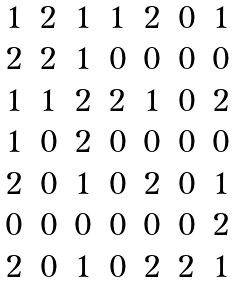<formula> <loc_0><loc_0><loc_500><loc_500>\begin{matrix} 1 & 2 & 1 & 1 & 2 & 0 & 1 \\ 2 & 2 & 1 & 0 & 0 & 0 & 0 \\ 1 & 1 & 2 & 2 & 1 & 0 & 2 \\ 1 & 0 & 2 & 0 & 0 & 0 & 0 \\ 2 & 0 & 1 & 0 & 2 & 0 & 1 \\ 0 & 0 & 0 & 0 & 0 & 0 & 2 \\ 2 & 0 & 1 & 0 & 2 & 2 & 1 \end{matrix}</formula> 